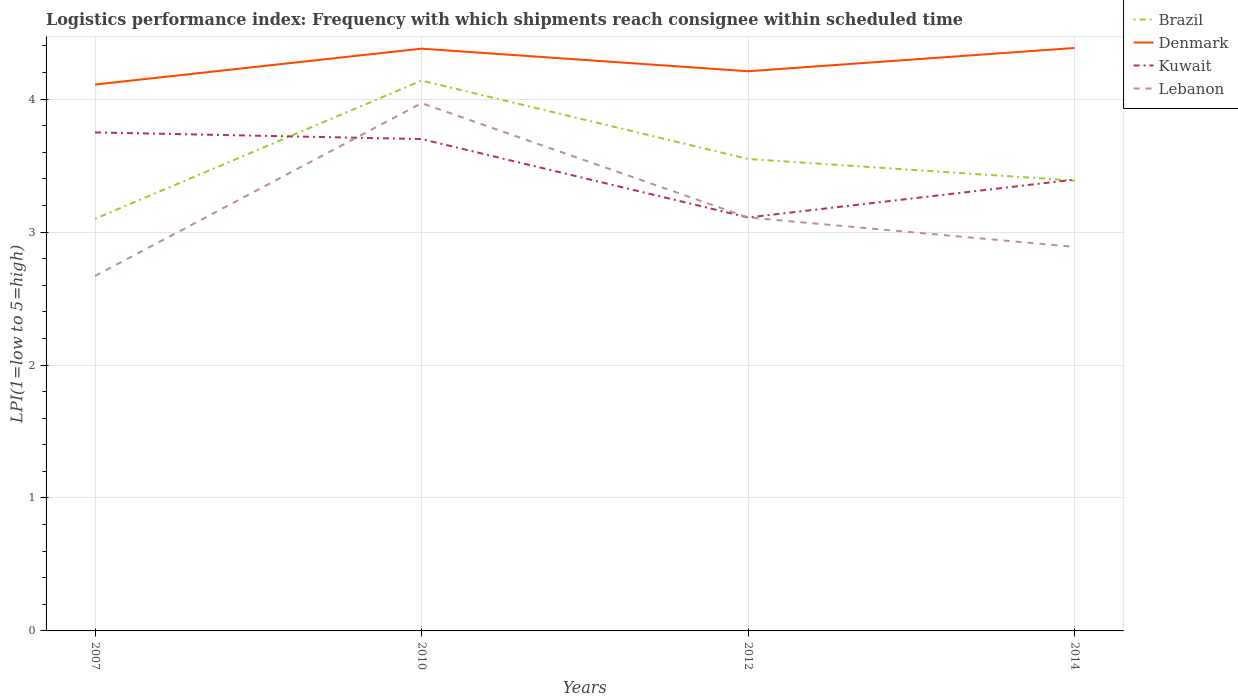Is the number of lines equal to the number of legend labels?
Offer a very short reply. Yes. Across all years, what is the maximum logistics performance index in Denmark?
Offer a terse response. 4.11. In which year was the logistics performance index in Denmark maximum?
Provide a succinct answer. 2007. What is the total logistics performance index in Lebanon in the graph?
Offer a very short reply. -1.3. What is the difference between the highest and the second highest logistics performance index in Denmark?
Ensure brevity in your answer.  0.28. How many lines are there?
Provide a short and direct response. 4. How many years are there in the graph?
Your answer should be very brief. 4. Does the graph contain any zero values?
Ensure brevity in your answer.  No. Where does the legend appear in the graph?
Ensure brevity in your answer.  Top right. How many legend labels are there?
Your answer should be compact. 4. What is the title of the graph?
Offer a terse response. Logistics performance index: Frequency with which shipments reach consignee within scheduled time. What is the label or title of the X-axis?
Your response must be concise. Years. What is the label or title of the Y-axis?
Provide a succinct answer. LPI(1=low to 5=high). What is the LPI(1=low to 5=high) of Denmark in 2007?
Your answer should be compact. 4.11. What is the LPI(1=low to 5=high) in Kuwait in 2007?
Offer a very short reply. 3.75. What is the LPI(1=low to 5=high) in Lebanon in 2007?
Keep it short and to the point. 2.67. What is the LPI(1=low to 5=high) of Brazil in 2010?
Offer a very short reply. 4.14. What is the LPI(1=low to 5=high) of Denmark in 2010?
Provide a succinct answer. 4.38. What is the LPI(1=low to 5=high) of Lebanon in 2010?
Keep it short and to the point. 3.97. What is the LPI(1=low to 5=high) of Brazil in 2012?
Provide a succinct answer. 3.55. What is the LPI(1=low to 5=high) in Denmark in 2012?
Keep it short and to the point. 4.21. What is the LPI(1=low to 5=high) of Kuwait in 2012?
Provide a short and direct response. 3.11. What is the LPI(1=low to 5=high) in Lebanon in 2012?
Keep it short and to the point. 3.11. What is the LPI(1=low to 5=high) in Brazil in 2014?
Your response must be concise. 3.39. What is the LPI(1=low to 5=high) in Denmark in 2014?
Make the answer very short. 4.39. What is the LPI(1=low to 5=high) in Kuwait in 2014?
Make the answer very short. 3.39. What is the LPI(1=low to 5=high) of Lebanon in 2014?
Provide a succinct answer. 2.89. Across all years, what is the maximum LPI(1=low to 5=high) in Brazil?
Your answer should be compact. 4.14. Across all years, what is the maximum LPI(1=low to 5=high) in Denmark?
Offer a very short reply. 4.39. Across all years, what is the maximum LPI(1=low to 5=high) of Kuwait?
Your answer should be compact. 3.75. Across all years, what is the maximum LPI(1=low to 5=high) of Lebanon?
Keep it short and to the point. 3.97. Across all years, what is the minimum LPI(1=low to 5=high) of Brazil?
Offer a terse response. 3.1. Across all years, what is the minimum LPI(1=low to 5=high) in Denmark?
Make the answer very short. 4.11. Across all years, what is the minimum LPI(1=low to 5=high) in Kuwait?
Make the answer very short. 3.11. Across all years, what is the minimum LPI(1=low to 5=high) in Lebanon?
Provide a short and direct response. 2.67. What is the total LPI(1=low to 5=high) of Brazil in the graph?
Your response must be concise. 14.18. What is the total LPI(1=low to 5=high) in Denmark in the graph?
Your answer should be very brief. 17.09. What is the total LPI(1=low to 5=high) in Kuwait in the graph?
Make the answer very short. 13.96. What is the total LPI(1=low to 5=high) in Lebanon in the graph?
Offer a terse response. 12.64. What is the difference between the LPI(1=low to 5=high) in Brazil in 2007 and that in 2010?
Your answer should be compact. -1.04. What is the difference between the LPI(1=low to 5=high) of Denmark in 2007 and that in 2010?
Provide a short and direct response. -0.27. What is the difference between the LPI(1=low to 5=high) of Kuwait in 2007 and that in 2010?
Provide a short and direct response. 0.05. What is the difference between the LPI(1=low to 5=high) of Brazil in 2007 and that in 2012?
Make the answer very short. -0.45. What is the difference between the LPI(1=low to 5=high) in Kuwait in 2007 and that in 2012?
Keep it short and to the point. 0.64. What is the difference between the LPI(1=low to 5=high) of Lebanon in 2007 and that in 2012?
Keep it short and to the point. -0.44. What is the difference between the LPI(1=low to 5=high) of Brazil in 2007 and that in 2014?
Your answer should be very brief. -0.29. What is the difference between the LPI(1=low to 5=high) of Denmark in 2007 and that in 2014?
Offer a terse response. -0.28. What is the difference between the LPI(1=low to 5=high) of Kuwait in 2007 and that in 2014?
Provide a succinct answer. 0.35. What is the difference between the LPI(1=low to 5=high) in Lebanon in 2007 and that in 2014?
Give a very brief answer. -0.22. What is the difference between the LPI(1=low to 5=high) of Brazil in 2010 and that in 2012?
Your answer should be compact. 0.59. What is the difference between the LPI(1=low to 5=high) in Denmark in 2010 and that in 2012?
Give a very brief answer. 0.17. What is the difference between the LPI(1=low to 5=high) in Kuwait in 2010 and that in 2012?
Provide a short and direct response. 0.59. What is the difference between the LPI(1=low to 5=high) of Lebanon in 2010 and that in 2012?
Offer a terse response. 0.86. What is the difference between the LPI(1=low to 5=high) in Brazil in 2010 and that in 2014?
Keep it short and to the point. 0.75. What is the difference between the LPI(1=low to 5=high) in Denmark in 2010 and that in 2014?
Ensure brevity in your answer.  -0.01. What is the difference between the LPI(1=low to 5=high) in Kuwait in 2010 and that in 2014?
Your answer should be compact. 0.3. What is the difference between the LPI(1=low to 5=high) in Lebanon in 2010 and that in 2014?
Offer a very short reply. 1.08. What is the difference between the LPI(1=low to 5=high) of Brazil in 2012 and that in 2014?
Ensure brevity in your answer.  0.16. What is the difference between the LPI(1=low to 5=high) of Denmark in 2012 and that in 2014?
Offer a very short reply. -0.18. What is the difference between the LPI(1=low to 5=high) in Kuwait in 2012 and that in 2014?
Your answer should be very brief. -0.28. What is the difference between the LPI(1=low to 5=high) of Lebanon in 2012 and that in 2014?
Provide a succinct answer. 0.22. What is the difference between the LPI(1=low to 5=high) in Brazil in 2007 and the LPI(1=low to 5=high) in Denmark in 2010?
Your answer should be compact. -1.28. What is the difference between the LPI(1=low to 5=high) of Brazil in 2007 and the LPI(1=low to 5=high) of Kuwait in 2010?
Offer a very short reply. -0.6. What is the difference between the LPI(1=low to 5=high) in Brazil in 2007 and the LPI(1=low to 5=high) in Lebanon in 2010?
Offer a very short reply. -0.87. What is the difference between the LPI(1=low to 5=high) of Denmark in 2007 and the LPI(1=low to 5=high) of Kuwait in 2010?
Provide a short and direct response. 0.41. What is the difference between the LPI(1=low to 5=high) of Denmark in 2007 and the LPI(1=low to 5=high) of Lebanon in 2010?
Offer a terse response. 0.14. What is the difference between the LPI(1=low to 5=high) in Kuwait in 2007 and the LPI(1=low to 5=high) in Lebanon in 2010?
Offer a very short reply. -0.22. What is the difference between the LPI(1=low to 5=high) of Brazil in 2007 and the LPI(1=low to 5=high) of Denmark in 2012?
Your answer should be compact. -1.11. What is the difference between the LPI(1=low to 5=high) in Brazil in 2007 and the LPI(1=low to 5=high) in Kuwait in 2012?
Provide a short and direct response. -0.01. What is the difference between the LPI(1=low to 5=high) in Brazil in 2007 and the LPI(1=low to 5=high) in Lebanon in 2012?
Keep it short and to the point. -0.01. What is the difference between the LPI(1=low to 5=high) in Denmark in 2007 and the LPI(1=low to 5=high) in Kuwait in 2012?
Make the answer very short. 1. What is the difference between the LPI(1=low to 5=high) of Denmark in 2007 and the LPI(1=low to 5=high) of Lebanon in 2012?
Provide a short and direct response. 1. What is the difference between the LPI(1=low to 5=high) in Kuwait in 2007 and the LPI(1=low to 5=high) in Lebanon in 2012?
Keep it short and to the point. 0.64. What is the difference between the LPI(1=low to 5=high) in Brazil in 2007 and the LPI(1=low to 5=high) in Denmark in 2014?
Give a very brief answer. -1.29. What is the difference between the LPI(1=low to 5=high) in Brazil in 2007 and the LPI(1=low to 5=high) in Kuwait in 2014?
Your response must be concise. -0.29. What is the difference between the LPI(1=low to 5=high) in Brazil in 2007 and the LPI(1=low to 5=high) in Lebanon in 2014?
Provide a short and direct response. 0.21. What is the difference between the LPI(1=low to 5=high) of Denmark in 2007 and the LPI(1=low to 5=high) of Kuwait in 2014?
Provide a succinct answer. 0.71. What is the difference between the LPI(1=low to 5=high) in Denmark in 2007 and the LPI(1=low to 5=high) in Lebanon in 2014?
Offer a very short reply. 1.22. What is the difference between the LPI(1=low to 5=high) of Kuwait in 2007 and the LPI(1=low to 5=high) of Lebanon in 2014?
Make the answer very short. 0.86. What is the difference between the LPI(1=low to 5=high) in Brazil in 2010 and the LPI(1=low to 5=high) in Denmark in 2012?
Provide a short and direct response. -0.07. What is the difference between the LPI(1=low to 5=high) in Brazil in 2010 and the LPI(1=low to 5=high) in Kuwait in 2012?
Your answer should be compact. 1.03. What is the difference between the LPI(1=low to 5=high) of Brazil in 2010 and the LPI(1=low to 5=high) of Lebanon in 2012?
Ensure brevity in your answer.  1.03. What is the difference between the LPI(1=low to 5=high) of Denmark in 2010 and the LPI(1=low to 5=high) of Kuwait in 2012?
Make the answer very short. 1.27. What is the difference between the LPI(1=low to 5=high) of Denmark in 2010 and the LPI(1=low to 5=high) of Lebanon in 2012?
Offer a terse response. 1.27. What is the difference between the LPI(1=low to 5=high) in Kuwait in 2010 and the LPI(1=low to 5=high) in Lebanon in 2012?
Make the answer very short. 0.59. What is the difference between the LPI(1=low to 5=high) in Brazil in 2010 and the LPI(1=low to 5=high) in Denmark in 2014?
Offer a terse response. -0.25. What is the difference between the LPI(1=low to 5=high) in Brazil in 2010 and the LPI(1=low to 5=high) in Kuwait in 2014?
Offer a terse response. 0.74. What is the difference between the LPI(1=low to 5=high) of Brazil in 2010 and the LPI(1=low to 5=high) of Lebanon in 2014?
Offer a very short reply. 1.25. What is the difference between the LPI(1=low to 5=high) in Denmark in 2010 and the LPI(1=low to 5=high) in Lebanon in 2014?
Keep it short and to the point. 1.49. What is the difference between the LPI(1=low to 5=high) in Kuwait in 2010 and the LPI(1=low to 5=high) in Lebanon in 2014?
Offer a terse response. 0.81. What is the difference between the LPI(1=low to 5=high) of Brazil in 2012 and the LPI(1=low to 5=high) of Denmark in 2014?
Provide a succinct answer. -0.84. What is the difference between the LPI(1=low to 5=high) of Brazil in 2012 and the LPI(1=low to 5=high) of Kuwait in 2014?
Offer a very short reply. 0.15. What is the difference between the LPI(1=low to 5=high) in Brazil in 2012 and the LPI(1=low to 5=high) in Lebanon in 2014?
Your answer should be very brief. 0.66. What is the difference between the LPI(1=low to 5=high) in Denmark in 2012 and the LPI(1=low to 5=high) in Kuwait in 2014?
Provide a short and direct response. 0.81. What is the difference between the LPI(1=low to 5=high) in Denmark in 2012 and the LPI(1=low to 5=high) in Lebanon in 2014?
Your answer should be compact. 1.32. What is the difference between the LPI(1=low to 5=high) in Kuwait in 2012 and the LPI(1=low to 5=high) in Lebanon in 2014?
Your response must be concise. 0.22. What is the average LPI(1=low to 5=high) in Brazil per year?
Keep it short and to the point. 3.54. What is the average LPI(1=low to 5=high) in Denmark per year?
Give a very brief answer. 4.27. What is the average LPI(1=low to 5=high) of Kuwait per year?
Your response must be concise. 3.49. What is the average LPI(1=low to 5=high) in Lebanon per year?
Keep it short and to the point. 3.16. In the year 2007, what is the difference between the LPI(1=low to 5=high) in Brazil and LPI(1=low to 5=high) in Denmark?
Offer a terse response. -1.01. In the year 2007, what is the difference between the LPI(1=low to 5=high) in Brazil and LPI(1=low to 5=high) in Kuwait?
Your response must be concise. -0.65. In the year 2007, what is the difference between the LPI(1=low to 5=high) of Brazil and LPI(1=low to 5=high) of Lebanon?
Offer a terse response. 0.43. In the year 2007, what is the difference between the LPI(1=low to 5=high) in Denmark and LPI(1=low to 5=high) in Kuwait?
Provide a succinct answer. 0.36. In the year 2007, what is the difference between the LPI(1=low to 5=high) in Denmark and LPI(1=low to 5=high) in Lebanon?
Provide a short and direct response. 1.44. In the year 2010, what is the difference between the LPI(1=low to 5=high) in Brazil and LPI(1=low to 5=high) in Denmark?
Your answer should be very brief. -0.24. In the year 2010, what is the difference between the LPI(1=low to 5=high) of Brazil and LPI(1=low to 5=high) of Kuwait?
Keep it short and to the point. 0.44. In the year 2010, what is the difference between the LPI(1=low to 5=high) of Brazil and LPI(1=low to 5=high) of Lebanon?
Your answer should be very brief. 0.17. In the year 2010, what is the difference between the LPI(1=low to 5=high) in Denmark and LPI(1=low to 5=high) in Kuwait?
Provide a succinct answer. 0.68. In the year 2010, what is the difference between the LPI(1=low to 5=high) of Denmark and LPI(1=low to 5=high) of Lebanon?
Make the answer very short. 0.41. In the year 2010, what is the difference between the LPI(1=low to 5=high) in Kuwait and LPI(1=low to 5=high) in Lebanon?
Your answer should be compact. -0.27. In the year 2012, what is the difference between the LPI(1=low to 5=high) in Brazil and LPI(1=low to 5=high) in Denmark?
Offer a very short reply. -0.66. In the year 2012, what is the difference between the LPI(1=low to 5=high) of Brazil and LPI(1=low to 5=high) of Kuwait?
Keep it short and to the point. 0.44. In the year 2012, what is the difference between the LPI(1=low to 5=high) of Brazil and LPI(1=low to 5=high) of Lebanon?
Provide a short and direct response. 0.44. In the year 2014, what is the difference between the LPI(1=low to 5=high) of Brazil and LPI(1=low to 5=high) of Denmark?
Provide a short and direct response. -1. In the year 2014, what is the difference between the LPI(1=low to 5=high) of Brazil and LPI(1=low to 5=high) of Kuwait?
Your answer should be compact. -0.01. In the year 2014, what is the difference between the LPI(1=low to 5=high) in Brazil and LPI(1=low to 5=high) in Lebanon?
Your answer should be very brief. 0.5. In the year 2014, what is the difference between the LPI(1=low to 5=high) of Denmark and LPI(1=low to 5=high) of Lebanon?
Offer a very short reply. 1.5. In the year 2014, what is the difference between the LPI(1=low to 5=high) in Kuwait and LPI(1=low to 5=high) in Lebanon?
Your answer should be very brief. 0.51. What is the ratio of the LPI(1=low to 5=high) of Brazil in 2007 to that in 2010?
Provide a succinct answer. 0.75. What is the ratio of the LPI(1=low to 5=high) in Denmark in 2007 to that in 2010?
Offer a terse response. 0.94. What is the ratio of the LPI(1=low to 5=high) in Kuwait in 2007 to that in 2010?
Ensure brevity in your answer.  1.01. What is the ratio of the LPI(1=low to 5=high) in Lebanon in 2007 to that in 2010?
Your response must be concise. 0.67. What is the ratio of the LPI(1=low to 5=high) of Brazil in 2007 to that in 2012?
Provide a short and direct response. 0.87. What is the ratio of the LPI(1=low to 5=high) of Denmark in 2007 to that in 2012?
Your answer should be compact. 0.98. What is the ratio of the LPI(1=low to 5=high) of Kuwait in 2007 to that in 2012?
Ensure brevity in your answer.  1.21. What is the ratio of the LPI(1=low to 5=high) in Lebanon in 2007 to that in 2012?
Your answer should be compact. 0.86. What is the ratio of the LPI(1=low to 5=high) of Brazil in 2007 to that in 2014?
Ensure brevity in your answer.  0.92. What is the ratio of the LPI(1=low to 5=high) in Denmark in 2007 to that in 2014?
Provide a short and direct response. 0.94. What is the ratio of the LPI(1=low to 5=high) of Kuwait in 2007 to that in 2014?
Provide a short and direct response. 1.1. What is the ratio of the LPI(1=low to 5=high) in Lebanon in 2007 to that in 2014?
Provide a succinct answer. 0.92. What is the ratio of the LPI(1=low to 5=high) of Brazil in 2010 to that in 2012?
Your response must be concise. 1.17. What is the ratio of the LPI(1=low to 5=high) of Denmark in 2010 to that in 2012?
Give a very brief answer. 1.04. What is the ratio of the LPI(1=low to 5=high) of Kuwait in 2010 to that in 2012?
Provide a short and direct response. 1.19. What is the ratio of the LPI(1=low to 5=high) in Lebanon in 2010 to that in 2012?
Ensure brevity in your answer.  1.28. What is the ratio of the LPI(1=low to 5=high) in Brazil in 2010 to that in 2014?
Your response must be concise. 1.22. What is the ratio of the LPI(1=low to 5=high) of Kuwait in 2010 to that in 2014?
Offer a terse response. 1.09. What is the ratio of the LPI(1=low to 5=high) in Lebanon in 2010 to that in 2014?
Provide a short and direct response. 1.37. What is the ratio of the LPI(1=low to 5=high) of Brazil in 2012 to that in 2014?
Provide a succinct answer. 1.05. What is the ratio of the LPI(1=low to 5=high) in Denmark in 2012 to that in 2014?
Your answer should be very brief. 0.96. What is the ratio of the LPI(1=low to 5=high) of Kuwait in 2012 to that in 2014?
Provide a succinct answer. 0.92. What is the ratio of the LPI(1=low to 5=high) of Lebanon in 2012 to that in 2014?
Offer a very short reply. 1.08. What is the difference between the highest and the second highest LPI(1=low to 5=high) of Brazil?
Give a very brief answer. 0.59. What is the difference between the highest and the second highest LPI(1=low to 5=high) of Denmark?
Keep it short and to the point. 0.01. What is the difference between the highest and the second highest LPI(1=low to 5=high) of Lebanon?
Ensure brevity in your answer.  0.86. What is the difference between the highest and the lowest LPI(1=low to 5=high) in Brazil?
Give a very brief answer. 1.04. What is the difference between the highest and the lowest LPI(1=low to 5=high) of Denmark?
Your answer should be very brief. 0.28. What is the difference between the highest and the lowest LPI(1=low to 5=high) in Kuwait?
Your answer should be very brief. 0.64. What is the difference between the highest and the lowest LPI(1=low to 5=high) of Lebanon?
Provide a succinct answer. 1.3. 